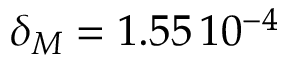<formula> <loc_0><loc_0><loc_500><loc_500>\delta _ { M } = 1 . 5 5 \, 1 0 ^ { - 4 }</formula> 